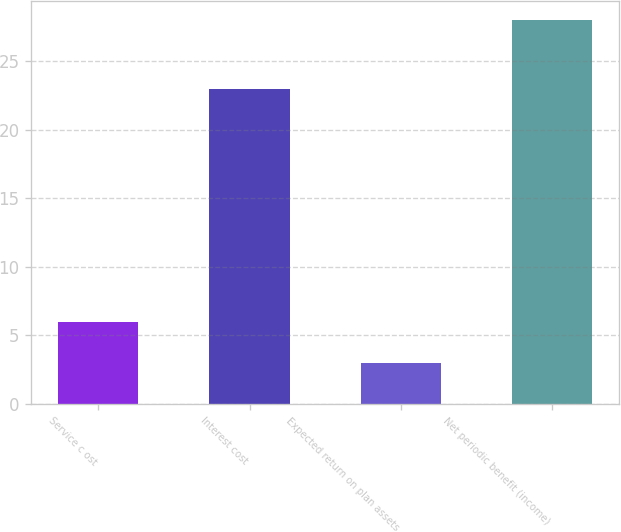Convert chart to OTSL. <chart><loc_0><loc_0><loc_500><loc_500><bar_chart><fcel>Service c ost<fcel>Interest cost<fcel>Expected return on plan assets<fcel>Net periodic benefit (income)<nl><fcel>6<fcel>23<fcel>3<fcel>28<nl></chart> 